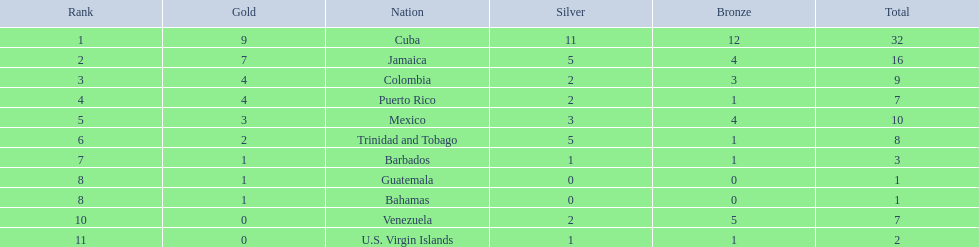Which 3 countries were awarded the most medals? Cuba, Jamaica, Colombia. Of these 3 countries which ones are islands? Cuba, Jamaica. Which one won the most silver medals? Cuba. 